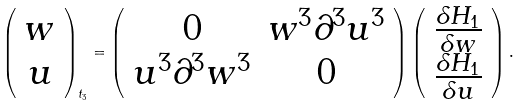Convert formula to latex. <formula><loc_0><loc_0><loc_500><loc_500>\left ( \begin{array} { c } w \\ u \end{array} \right ) _ { t _ { 3 } } = \left ( \begin{array} { c c } 0 & w ^ { 3 } \partial ^ { 3 } u ^ { 3 } \\ u ^ { 3 } \partial ^ { 3 } w ^ { 3 } & 0 \end{array} \right ) \left ( \begin{array} { c } \frac { \delta H _ { 1 } } { \delta w } \\ \frac { \delta H _ { 1 } } { \delta u } \end{array} \right ) .</formula> 